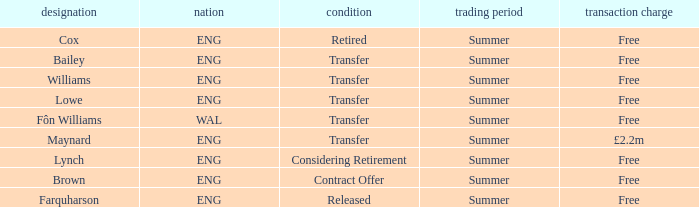What is the status of the ENG Country with the name of Farquharson? Released. 